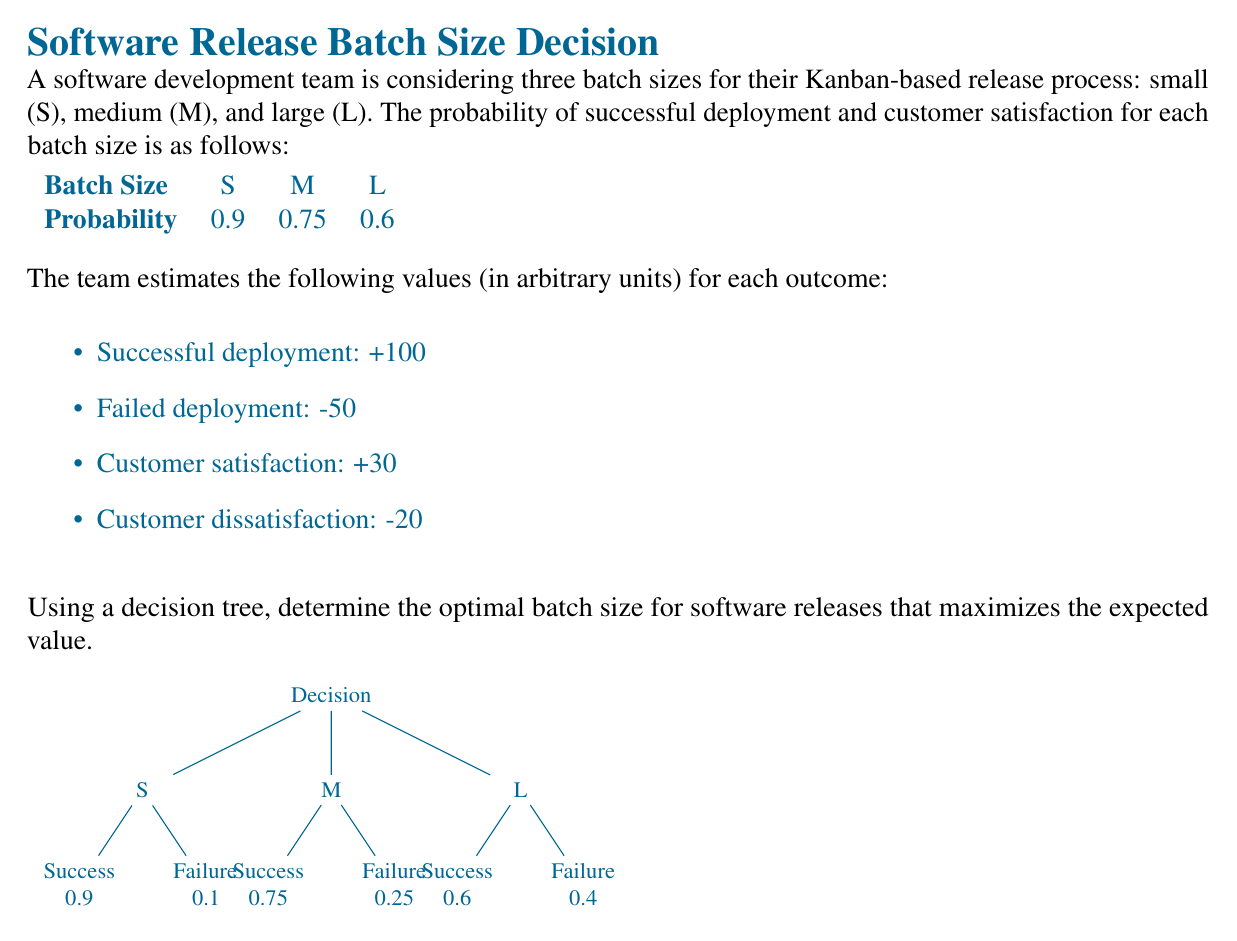Provide a solution to this math problem. Let's calculate the expected value for each batch size:

1. Small (S) batch size:
   $$EV(S) = 0.9 \times (100 + 30) + 0.1 \times (-50 - 20)$$
   $$EV(S) = 0.9 \times 130 + 0.1 \times (-70)$$
   $$EV(S) = 117 - 7 = 110$$

2. Medium (M) batch size:
   $$EV(M) = 0.75 \times (100 + 30) + 0.25 \times (-50 - 20)$$
   $$EV(M) = 0.75 \times 130 + 0.25 \times (-70)$$
   $$EV(M) = 97.5 - 17.5 = 80$$

3. Large (L) batch size:
   $$EV(L) = 0.6 \times (100 + 30) + 0.4 \times (-50 - 20)$$
   $$EV(L) = 0.6 \times 130 + 0.4 \times (-70)$$
   $$EV(L) = 78 - 28 = 50$$

Comparing the expected values:
$$EV(S) > EV(M) > EV(L)$$
$$110 > 80 > 50$$

Therefore, the optimal batch size for software releases that maximizes the expected value is the small (S) batch size.
Answer: Small (S) batch size 